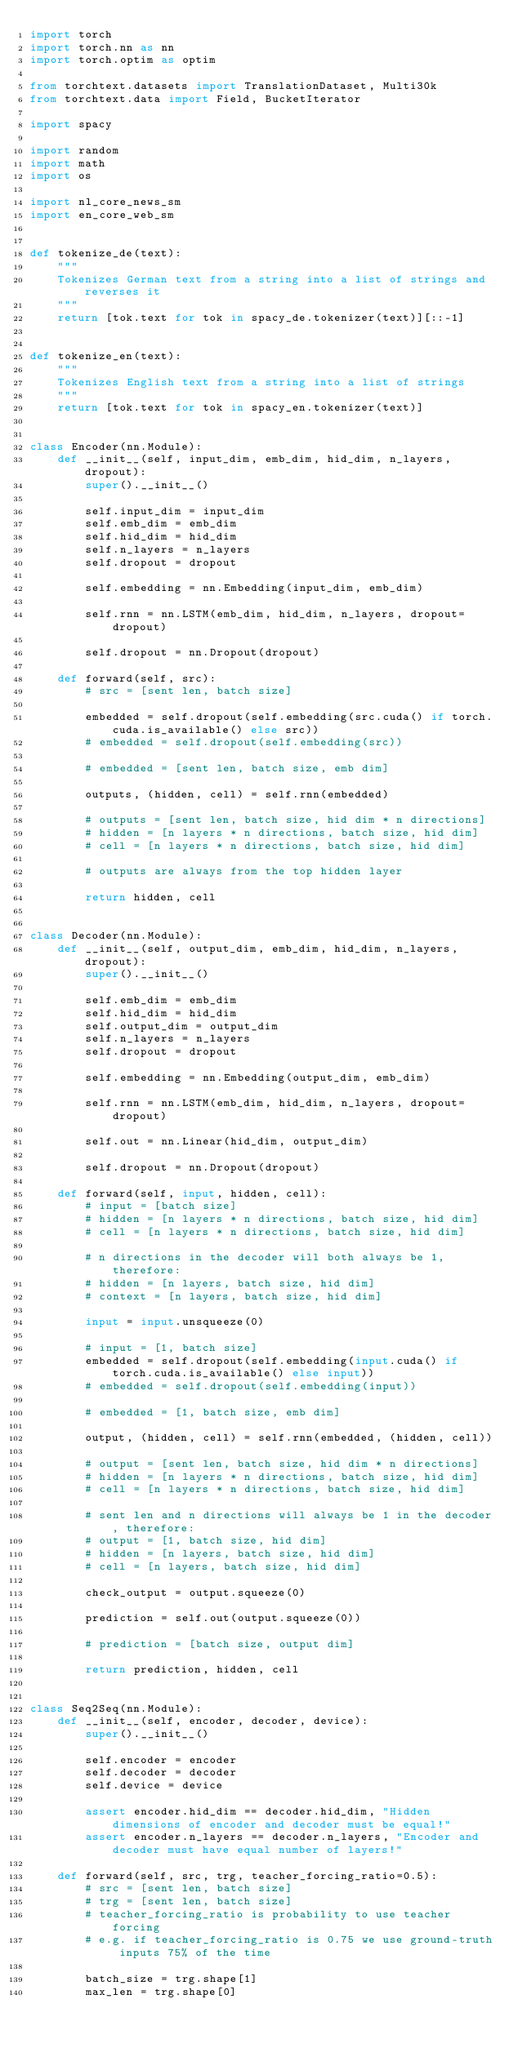<code> <loc_0><loc_0><loc_500><loc_500><_Python_>import torch
import torch.nn as nn
import torch.optim as optim

from torchtext.datasets import TranslationDataset, Multi30k
from torchtext.data import Field, BucketIterator

import spacy

import random
import math
import os

import nl_core_news_sm
import en_core_web_sm


def tokenize_de(text):
    """
    Tokenizes German text from a string into a list of strings and reverses it
    """
    return [tok.text for tok in spacy_de.tokenizer(text)][::-1]


def tokenize_en(text):
    """
    Tokenizes English text from a string into a list of strings
    """
    return [tok.text for tok in spacy_en.tokenizer(text)]


class Encoder(nn.Module):
    def __init__(self, input_dim, emb_dim, hid_dim, n_layers, dropout):
        super().__init__()

        self.input_dim = input_dim
        self.emb_dim = emb_dim
        self.hid_dim = hid_dim
        self.n_layers = n_layers
        self.dropout = dropout

        self.embedding = nn.Embedding(input_dim, emb_dim)

        self.rnn = nn.LSTM(emb_dim, hid_dim, n_layers, dropout=dropout)

        self.dropout = nn.Dropout(dropout)

    def forward(self, src):
        # src = [sent len, batch size]

        embedded = self.dropout(self.embedding(src.cuda() if torch.cuda.is_available() else src))
        # embedded = self.dropout(self.embedding(src))

        # embedded = [sent len, batch size, emb dim]

        outputs, (hidden, cell) = self.rnn(embedded)

        # outputs = [sent len, batch size, hid dim * n directions]
        # hidden = [n layers * n directions, batch size, hid dim]
        # cell = [n layers * n directions, batch size, hid dim]

        # outputs are always from the top hidden layer

        return hidden, cell


class Decoder(nn.Module):
    def __init__(self, output_dim, emb_dim, hid_dim, n_layers, dropout):
        super().__init__()

        self.emb_dim = emb_dim
        self.hid_dim = hid_dim
        self.output_dim = output_dim
        self.n_layers = n_layers
        self.dropout = dropout

        self.embedding = nn.Embedding(output_dim, emb_dim)

        self.rnn = nn.LSTM(emb_dim, hid_dim, n_layers, dropout=dropout)

        self.out = nn.Linear(hid_dim, output_dim)

        self.dropout = nn.Dropout(dropout)

    def forward(self, input, hidden, cell):
        # input = [batch size]
        # hidden = [n layers * n directions, batch size, hid dim]
        # cell = [n layers * n directions, batch size, hid dim]

        # n directions in the decoder will both always be 1, therefore:
        # hidden = [n layers, batch size, hid dim]
        # context = [n layers, batch size, hid dim]

        input = input.unsqueeze(0)

        # input = [1, batch size]
        embedded = self.dropout(self.embedding(input.cuda() if torch.cuda.is_available() else input))
        # embedded = self.dropout(self.embedding(input))

        # embedded = [1, batch size, emb dim]

        output, (hidden, cell) = self.rnn(embedded, (hidden, cell))

        # output = [sent len, batch size, hid dim * n directions]
        # hidden = [n layers * n directions, batch size, hid dim]
        # cell = [n layers * n directions, batch size, hid dim]

        # sent len and n directions will always be 1 in the decoder, therefore:
        # output = [1, batch size, hid dim]
        # hidden = [n layers, batch size, hid dim]
        # cell = [n layers, batch size, hid dim]

        check_output = output.squeeze(0)

        prediction = self.out(output.squeeze(0))

        # prediction = [batch size, output dim]

        return prediction, hidden, cell


class Seq2Seq(nn.Module):
    def __init__(self, encoder, decoder, device):
        super().__init__()

        self.encoder = encoder
        self.decoder = decoder
        self.device = device

        assert encoder.hid_dim == decoder.hid_dim, "Hidden dimensions of encoder and decoder must be equal!"
        assert encoder.n_layers == decoder.n_layers, "Encoder and decoder must have equal number of layers!"

    def forward(self, src, trg, teacher_forcing_ratio=0.5):
        # src = [sent len, batch size]
        # trg = [sent len, batch size]
        # teacher_forcing_ratio is probability to use teacher forcing
        # e.g. if teacher_forcing_ratio is 0.75 we use ground-truth inputs 75% of the time

        batch_size = trg.shape[1]
        max_len = trg.shape[0]</code> 